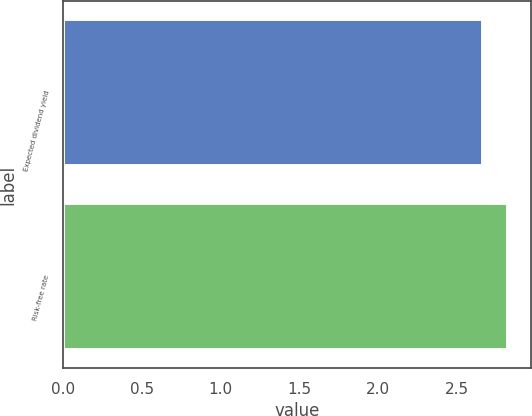Convert chart to OTSL. <chart><loc_0><loc_0><loc_500><loc_500><bar_chart><fcel>Expected dividend yield<fcel>Risk-free rate<nl><fcel>2.67<fcel>2.83<nl></chart> 